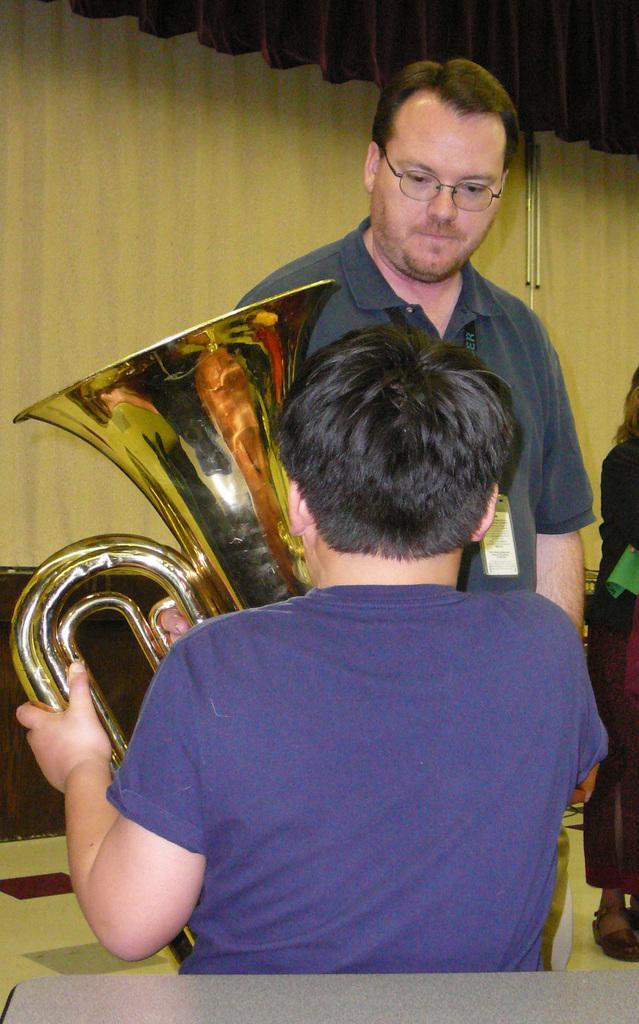Can you describe this image briefly? As we can see in the image there are few people here and there, curtain and musical instrument. 